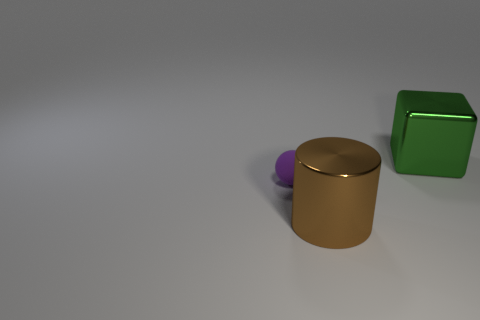Is there any other thing that has the same size as the ball?
Your answer should be compact. No. Is there another brown rubber cylinder of the same size as the cylinder?
Your answer should be compact. No. How many things are big shiny things on the right side of the large brown metallic thing or metal objects that are in front of the cube?
Offer a terse response. 2. There is a shiny object behind the brown metallic cylinder; is its size the same as the brown metallic thing that is in front of the big metallic block?
Provide a succinct answer. Yes. Is there a big brown cylinder that is in front of the metal object that is in front of the purple rubber thing?
Give a very brief answer. No. What number of metal things are behind the small purple sphere?
Ensure brevity in your answer.  1. Is the number of metal things to the right of the green shiny thing less than the number of metal blocks to the right of the small purple rubber sphere?
Keep it short and to the point. Yes. What number of things are objects that are left of the big green cube or big metal things?
Offer a very short reply. 3. Does the purple ball have the same size as the thing that is in front of the purple matte sphere?
Offer a very short reply. No. How many brown shiny objects are to the left of the shiny object on the right side of the big shiny cylinder to the right of the rubber sphere?
Make the answer very short. 1. 